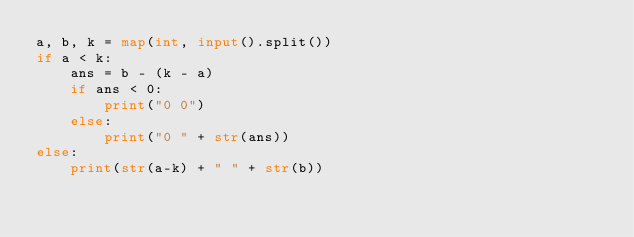<code> <loc_0><loc_0><loc_500><loc_500><_Python_>a, b, k = map(int, input().split())
if a < k:
    ans = b - (k - a)
    if ans < 0:
        print("0 0")
    else:
        print("0 " + str(ans))
else:
    print(str(a-k) + " " + str(b))</code> 